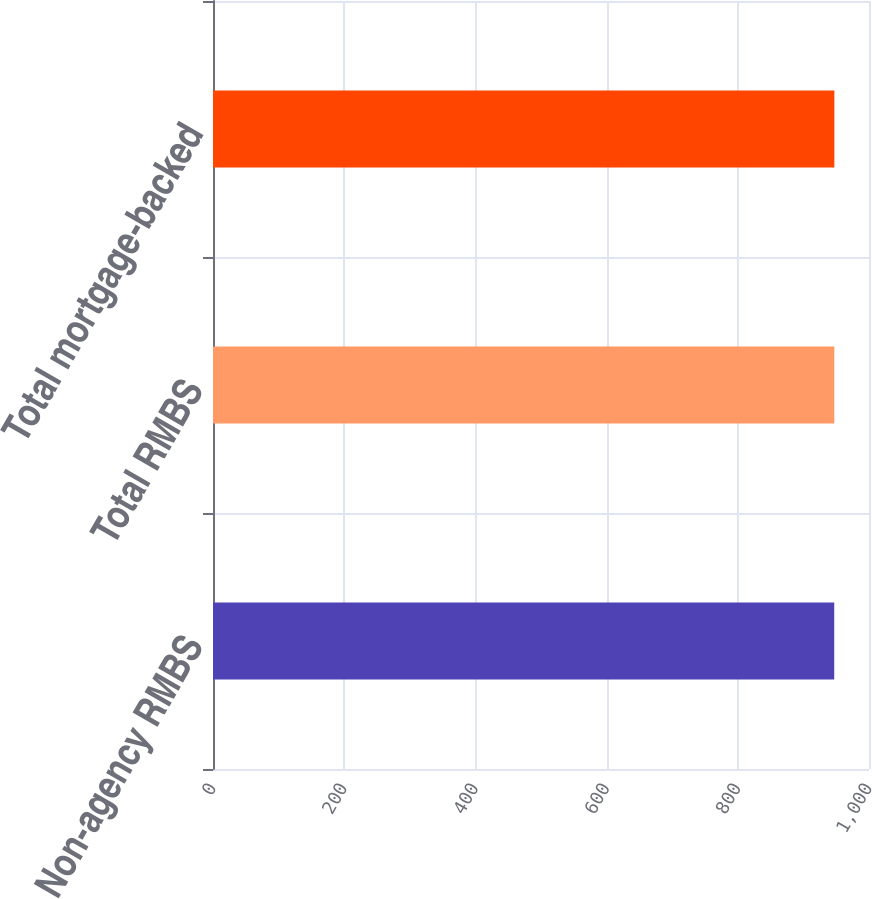Convert chart to OTSL. <chart><loc_0><loc_0><loc_500><loc_500><bar_chart><fcel>Non-agency RMBS<fcel>Total RMBS<fcel>Total mortgage-backed<nl><fcel>947<fcel>947.1<fcel>947.2<nl></chart> 